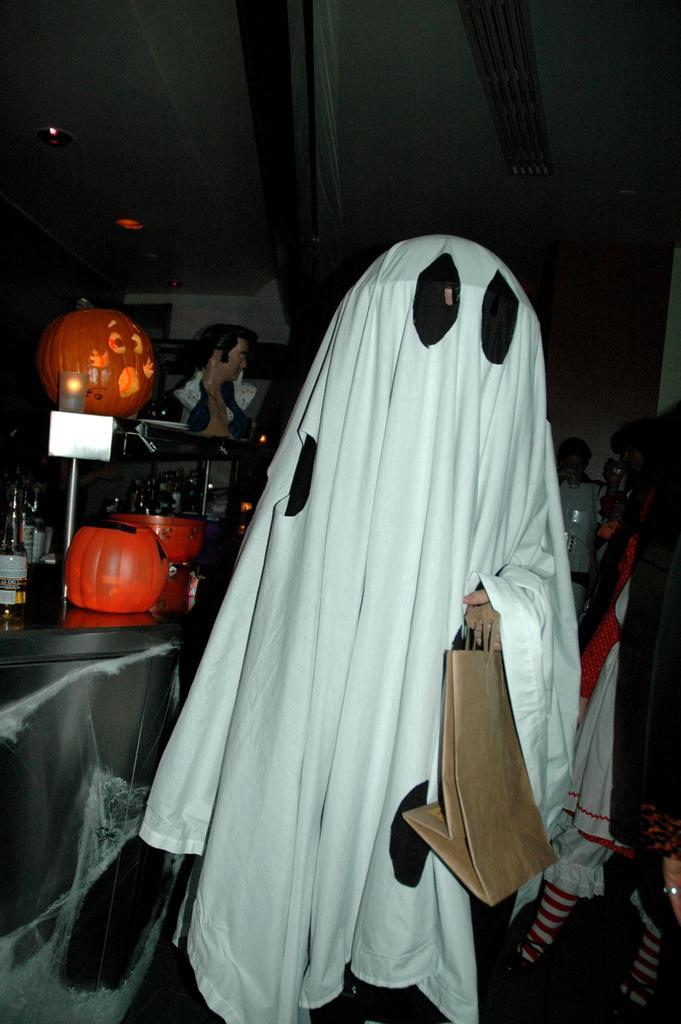Describe this image in one or two sentences. In this image a person is wearing costume and holding a bag in his hand, on the left side there is a table, on that table there are bottles and a toy, in the background there are people. 